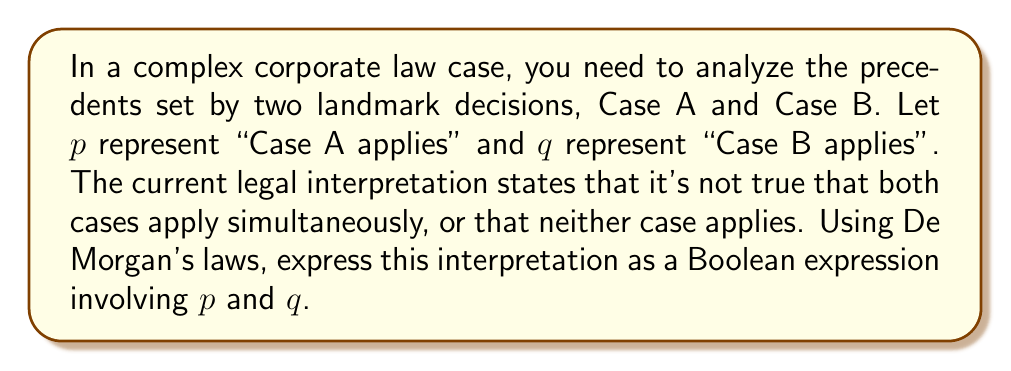Can you solve this math problem? Let's approach this step-by-step:

1) First, let's translate the given statement into Boolean logic:
   "It's not true that both cases apply simultaneously, or that neither case applies"

   This can be written as: $\neg((p \wedge q) \vee (\neg p \wedge \neg q))$

2) Now, we can apply De Morgan's first law to this expression:
   $\neg(A \vee B) \equiv \neg A \wedge \neg B$

   In our case, $A = (p \wedge q)$ and $B = (\neg p \wedge \neg q)$

   So, $\neg((p \wedge q) \vee (\neg p \wedge \neg q)) \equiv \neg(p \wedge q) \wedge \neg(\neg p \wedge \neg q)$

3) Now we can apply De Morgan's second law to each part:
   $\neg(A \wedge B) \equiv \neg A \vee \neg B$

   For the first part: $\neg(p \wedge q) \equiv \neg p \vee \neg q$
   For the second part: $\neg(\neg p \wedge \neg q) \equiv p \vee q$

4) Substituting these back:
   $(\neg p \vee \neg q) \wedge (p \vee q)$

This final expression represents the legal interpretation using De Morgan's laws.
Answer: $(\neg p \vee \neg q) \wedge (p \vee q)$ 